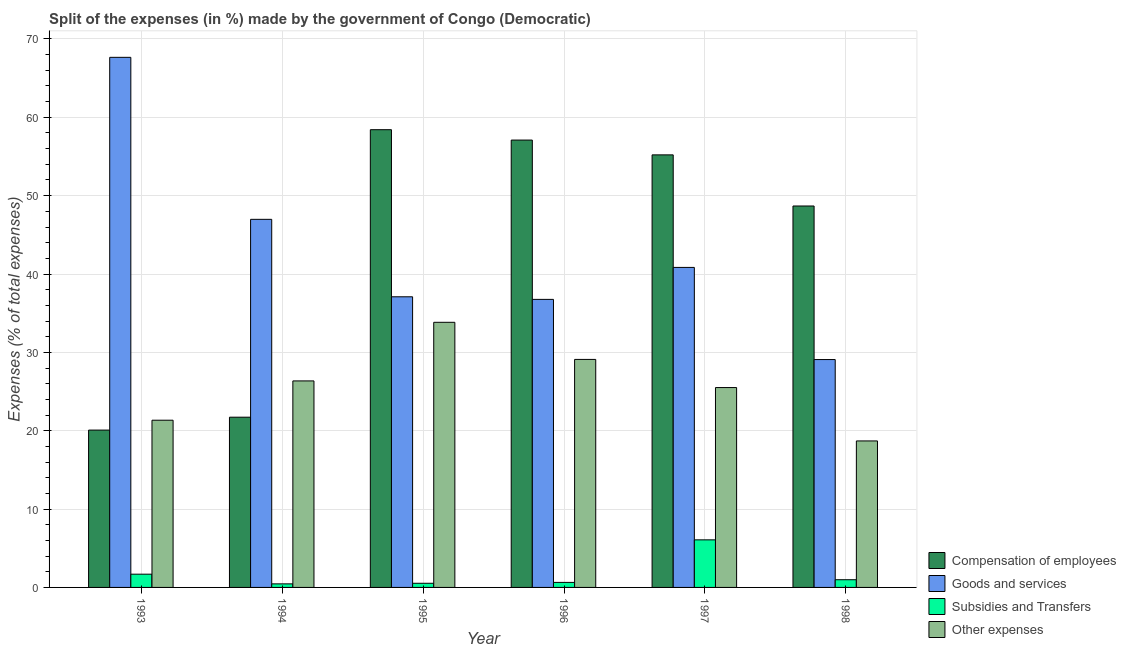How many groups of bars are there?
Provide a succinct answer. 6. What is the percentage of amount spent on other expenses in 1996?
Provide a short and direct response. 29.1. Across all years, what is the maximum percentage of amount spent on compensation of employees?
Give a very brief answer. 58.42. Across all years, what is the minimum percentage of amount spent on subsidies?
Keep it short and to the point. 0.45. In which year was the percentage of amount spent on goods and services minimum?
Ensure brevity in your answer.  1998. What is the total percentage of amount spent on compensation of employees in the graph?
Your answer should be very brief. 261.21. What is the difference between the percentage of amount spent on compensation of employees in 1994 and that in 1996?
Offer a very short reply. -35.37. What is the difference between the percentage of amount spent on other expenses in 1997 and the percentage of amount spent on compensation of employees in 1994?
Keep it short and to the point. -0.85. What is the average percentage of amount spent on goods and services per year?
Give a very brief answer. 43.07. In how many years, is the percentage of amount spent on subsidies greater than 4 %?
Provide a succinct answer. 1. What is the ratio of the percentage of amount spent on goods and services in 1994 to that in 1995?
Your answer should be very brief. 1.27. What is the difference between the highest and the second highest percentage of amount spent on compensation of employees?
Offer a terse response. 1.32. What is the difference between the highest and the lowest percentage of amount spent on other expenses?
Your answer should be very brief. 15.14. In how many years, is the percentage of amount spent on subsidies greater than the average percentage of amount spent on subsidies taken over all years?
Give a very brief answer. 1. Is it the case that in every year, the sum of the percentage of amount spent on goods and services and percentage of amount spent on compensation of employees is greater than the sum of percentage of amount spent on other expenses and percentage of amount spent on subsidies?
Provide a short and direct response. Yes. What does the 1st bar from the left in 1994 represents?
Give a very brief answer. Compensation of employees. What does the 3rd bar from the right in 1995 represents?
Give a very brief answer. Goods and services. Is it the case that in every year, the sum of the percentage of amount spent on compensation of employees and percentage of amount spent on goods and services is greater than the percentage of amount spent on subsidies?
Give a very brief answer. Yes. How many bars are there?
Keep it short and to the point. 24. What is the difference between two consecutive major ticks on the Y-axis?
Ensure brevity in your answer.  10. Does the graph contain grids?
Provide a succinct answer. Yes. Where does the legend appear in the graph?
Ensure brevity in your answer.  Bottom right. What is the title of the graph?
Your answer should be very brief. Split of the expenses (in %) made by the government of Congo (Democratic). Does "Norway" appear as one of the legend labels in the graph?
Your answer should be compact. No. What is the label or title of the X-axis?
Your answer should be compact. Year. What is the label or title of the Y-axis?
Your response must be concise. Expenses (% of total expenses). What is the Expenses (% of total expenses) of Compensation of employees in 1993?
Keep it short and to the point. 20.08. What is the Expenses (% of total expenses) of Goods and services in 1993?
Your answer should be compact. 67.66. What is the Expenses (% of total expenses) of Subsidies and Transfers in 1993?
Your answer should be very brief. 1.69. What is the Expenses (% of total expenses) of Other expenses in 1993?
Provide a short and direct response. 21.34. What is the Expenses (% of total expenses) in Compensation of employees in 1994?
Make the answer very short. 21.73. What is the Expenses (% of total expenses) of Goods and services in 1994?
Make the answer very short. 46.98. What is the Expenses (% of total expenses) in Subsidies and Transfers in 1994?
Provide a succinct answer. 0.45. What is the Expenses (% of total expenses) in Other expenses in 1994?
Your response must be concise. 26.36. What is the Expenses (% of total expenses) of Compensation of employees in 1995?
Give a very brief answer. 58.42. What is the Expenses (% of total expenses) of Goods and services in 1995?
Offer a terse response. 37.09. What is the Expenses (% of total expenses) of Subsidies and Transfers in 1995?
Your response must be concise. 0.53. What is the Expenses (% of total expenses) of Other expenses in 1995?
Provide a succinct answer. 33.84. What is the Expenses (% of total expenses) in Compensation of employees in 1996?
Your response must be concise. 57.1. What is the Expenses (% of total expenses) of Goods and services in 1996?
Your response must be concise. 36.76. What is the Expenses (% of total expenses) in Subsidies and Transfers in 1996?
Provide a succinct answer. 0.64. What is the Expenses (% of total expenses) in Other expenses in 1996?
Offer a very short reply. 29.1. What is the Expenses (% of total expenses) of Compensation of employees in 1997?
Make the answer very short. 55.21. What is the Expenses (% of total expenses) of Goods and services in 1997?
Your answer should be compact. 40.84. What is the Expenses (% of total expenses) of Subsidies and Transfers in 1997?
Your answer should be compact. 6.07. What is the Expenses (% of total expenses) in Other expenses in 1997?
Offer a very short reply. 25.51. What is the Expenses (% of total expenses) in Compensation of employees in 1998?
Your answer should be compact. 48.68. What is the Expenses (% of total expenses) in Goods and services in 1998?
Your response must be concise. 29.08. What is the Expenses (% of total expenses) of Subsidies and Transfers in 1998?
Offer a very short reply. 0.98. What is the Expenses (% of total expenses) in Other expenses in 1998?
Offer a very short reply. 18.7. Across all years, what is the maximum Expenses (% of total expenses) of Compensation of employees?
Give a very brief answer. 58.42. Across all years, what is the maximum Expenses (% of total expenses) in Goods and services?
Give a very brief answer. 67.66. Across all years, what is the maximum Expenses (% of total expenses) in Subsidies and Transfers?
Your answer should be compact. 6.07. Across all years, what is the maximum Expenses (% of total expenses) of Other expenses?
Your response must be concise. 33.84. Across all years, what is the minimum Expenses (% of total expenses) of Compensation of employees?
Give a very brief answer. 20.08. Across all years, what is the minimum Expenses (% of total expenses) in Goods and services?
Your response must be concise. 29.08. Across all years, what is the minimum Expenses (% of total expenses) of Subsidies and Transfers?
Ensure brevity in your answer.  0.45. Across all years, what is the minimum Expenses (% of total expenses) of Other expenses?
Provide a short and direct response. 18.7. What is the total Expenses (% of total expenses) in Compensation of employees in the graph?
Offer a very short reply. 261.21. What is the total Expenses (% of total expenses) of Goods and services in the graph?
Your answer should be very brief. 258.42. What is the total Expenses (% of total expenses) of Subsidies and Transfers in the graph?
Provide a succinct answer. 10.37. What is the total Expenses (% of total expenses) of Other expenses in the graph?
Give a very brief answer. 154.84. What is the difference between the Expenses (% of total expenses) in Compensation of employees in 1993 and that in 1994?
Offer a very short reply. -1.65. What is the difference between the Expenses (% of total expenses) of Goods and services in 1993 and that in 1994?
Your response must be concise. 20.68. What is the difference between the Expenses (% of total expenses) in Subsidies and Transfers in 1993 and that in 1994?
Provide a succinct answer. 1.24. What is the difference between the Expenses (% of total expenses) of Other expenses in 1993 and that in 1994?
Ensure brevity in your answer.  -5.01. What is the difference between the Expenses (% of total expenses) in Compensation of employees in 1993 and that in 1995?
Give a very brief answer. -38.34. What is the difference between the Expenses (% of total expenses) in Goods and services in 1993 and that in 1995?
Your response must be concise. 30.56. What is the difference between the Expenses (% of total expenses) in Subsidies and Transfers in 1993 and that in 1995?
Your answer should be compact. 1.16. What is the difference between the Expenses (% of total expenses) of Other expenses in 1993 and that in 1995?
Give a very brief answer. -12.5. What is the difference between the Expenses (% of total expenses) of Compensation of employees in 1993 and that in 1996?
Give a very brief answer. -37.02. What is the difference between the Expenses (% of total expenses) of Goods and services in 1993 and that in 1996?
Provide a short and direct response. 30.89. What is the difference between the Expenses (% of total expenses) of Subsidies and Transfers in 1993 and that in 1996?
Your answer should be compact. 1.05. What is the difference between the Expenses (% of total expenses) of Other expenses in 1993 and that in 1996?
Provide a short and direct response. -7.76. What is the difference between the Expenses (% of total expenses) of Compensation of employees in 1993 and that in 1997?
Offer a terse response. -35.13. What is the difference between the Expenses (% of total expenses) in Goods and services in 1993 and that in 1997?
Your answer should be very brief. 26.81. What is the difference between the Expenses (% of total expenses) in Subsidies and Transfers in 1993 and that in 1997?
Provide a short and direct response. -4.38. What is the difference between the Expenses (% of total expenses) in Other expenses in 1993 and that in 1997?
Offer a very short reply. -4.17. What is the difference between the Expenses (% of total expenses) in Compensation of employees in 1993 and that in 1998?
Your answer should be very brief. -28.6. What is the difference between the Expenses (% of total expenses) in Goods and services in 1993 and that in 1998?
Provide a succinct answer. 38.57. What is the difference between the Expenses (% of total expenses) in Subsidies and Transfers in 1993 and that in 1998?
Your answer should be compact. 0.71. What is the difference between the Expenses (% of total expenses) in Other expenses in 1993 and that in 1998?
Provide a short and direct response. 2.65. What is the difference between the Expenses (% of total expenses) of Compensation of employees in 1994 and that in 1995?
Give a very brief answer. -36.69. What is the difference between the Expenses (% of total expenses) in Goods and services in 1994 and that in 1995?
Your response must be concise. 9.89. What is the difference between the Expenses (% of total expenses) in Subsidies and Transfers in 1994 and that in 1995?
Provide a short and direct response. -0.08. What is the difference between the Expenses (% of total expenses) of Other expenses in 1994 and that in 1995?
Keep it short and to the point. -7.48. What is the difference between the Expenses (% of total expenses) in Compensation of employees in 1994 and that in 1996?
Provide a succinct answer. -35.37. What is the difference between the Expenses (% of total expenses) in Goods and services in 1994 and that in 1996?
Make the answer very short. 10.22. What is the difference between the Expenses (% of total expenses) in Subsidies and Transfers in 1994 and that in 1996?
Your answer should be compact. -0.19. What is the difference between the Expenses (% of total expenses) in Other expenses in 1994 and that in 1996?
Your answer should be very brief. -2.74. What is the difference between the Expenses (% of total expenses) in Compensation of employees in 1994 and that in 1997?
Make the answer very short. -33.48. What is the difference between the Expenses (% of total expenses) of Goods and services in 1994 and that in 1997?
Provide a short and direct response. 6.14. What is the difference between the Expenses (% of total expenses) of Subsidies and Transfers in 1994 and that in 1997?
Your answer should be compact. -5.62. What is the difference between the Expenses (% of total expenses) in Other expenses in 1994 and that in 1997?
Keep it short and to the point. 0.85. What is the difference between the Expenses (% of total expenses) in Compensation of employees in 1994 and that in 1998?
Give a very brief answer. -26.95. What is the difference between the Expenses (% of total expenses) in Goods and services in 1994 and that in 1998?
Your answer should be compact. 17.9. What is the difference between the Expenses (% of total expenses) in Subsidies and Transfers in 1994 and that in 1998?
Offer a terse response. -0.53. What is the difference between the Expenses (% of total expenses) in Other expenses in 1994 and that in 1998?
Provide a succinct answer. 7.66. What is the difference between the Expenses (% of total expenses) of Compensation of employees in 1995 and that in 1996?
Keep it short and to the point. 1.32. What is the difference between the Expenses (% of total expenses) of Goods and services in 1995 and that in 1996?
Keep it short and to the point. 0.33. What is the difference between the Expenses (% of total expenses) of Subsidies and Transfers in 1995 and that in 1996?
Provide a succinct answer. -0.11. What is the difference between the Expenses (% of total expenses) of Other expenses in 1995 and that in 1996?
Your answer should be very brief. 4.74. What is the difference between the Expenses (% of total expenses) in Compensation of employees in 1995 and that in 1997?
Offer a terse response. 3.21. What is the difference between the Expenses (% of total expenses) in Goods and services in 1995 and that in 1997?
Provide a short and direct response. -3.75. What is the difference between the Expenses (% of total expenses) in Subsidies and Transfers in 1995 and that in 1997?
Make the answer very short. -5.54. What is the difference between the Expenses (% of total expenses) of Other expenses in 1995 and that in 1997?
Keep it short and to the point. 8.33. What is the difference between the Expenses (% of total expenses) in Compensation of employees in 1995 and that in 1998?
Offer a terse response. 9.74. What is the difference between the Expenses (% of total expenses) of Goods and services in 1995 and that in 1998?
Give a very brief answer. 8.01. What is the difference between the Expenses (% of total expenses) of Subsidies and Transfers in 1995 and that in 1998?
Make the answer very short. -0.45. What is the difference between the Expenses (% of total expenses) of Other expenses in 1995 and that in 1998?
Give a very brief answer. 15.14. What is the difference between the Expenses (% of total expenses) in Compensation of employees in 1996 and that in 1997?
Provide a succinct answer. 1.89. What is the difference between the Expenses (% of total expenses) of Goods and services in 1996 and that in 1997?
Your answer should be very brief. -4.08. What is the difference between the Expenses (% of total expenses) of Subsidies and Transfers in 1996 and that in 1997?
Provide a succinct answer. -5.43. What is the difference between the Expenses (% of total expenses) in Other expenses in 1996 and that in 1997?
Ensure brevity in your answer.  3.59. What is the difference between the Expenses (% of total expenses) of Compensation of employees in 1996 and that in 1998?
Your response must be concise. 8.41. What is the difference between the Expenses (% of total expenses) of Goods and services in 1996 and that in 1998?
Make the answer very short. 7.68. What is the difference between the Expenses (% of total expenses) in Subsidies and Transfers in 1996 and that in 1998?
Keep it short and to the point. -0.34. What is the difference between the Expenses (% of total expenses) of Other expenses in 1996 and that in 1998?
Ensure brevity in your answer.  10.4. What is the difference between the Expenses (% of total expenses) in Compensation of employees in 1997 and that in 1998?
Provide a short and direct response. 6.52. What is the difference between the Expenses (% of total expenses) in Goods and services in 1997 and that in 1998?
Offer a terse response. 11.76. What is the difference between the Expenses (% of total expenses) of Subsidies and Transfers in 1997 and that in 1998?
Provide a short and direct response. 5.09. What is the difference between the Expenses (% of total expenses) in Other expenses in 1997 and that in 1998?
Offer a very short reply. 6.81. What is the difference between the Expenses (% of total expenses) in Compensation of employees in 1993 and the Expenses (% of total expenses) in Goods and services in 1994?
Offer a terse response. -26.9. What is the difference between the Expenses (% of total expenses) in Compensation of employees in 1993 and the Expenses (% of total expenses) in Subsidies and Transfers in 1994?
Give a very brief answer. 19.63. What is the difference between the Expenses (% of total expenses) in Compensation of employees in 1993 and the Expenses (% of total expenses) in Other expenses in 1994?
Offer a terse response. -6.28. What is the difference between the Expenses (% of total expenses) in Goods and services in 1993 and the Expenses (% of total expenses) in Subsidies and Transfers in 1994?
Your response must be concise. 67.2. What is the difference between the Expenses (% of total expenses) in Goods and services in 1993 and the Expenses (% of total expenses) in Other expenses in 1994?
Your answer should be compact. 41.3. What is the difference between the Expenses (% of total expenses) of Subsidies and Transfers in 1993 and the Expenses (% of total expenses) of Other expenses in 1994?
Keep it short and to the point. -24.67. What is the difference between the Expenses (% of total expenses) of Compensation of employees in 1993 and the Expenses (% of total expenses) of Goods and services in 1995?
Your response must be concise. -17.01. What is the difference between the Expenses (% of total expenses) of Compensation of employees in 1993 and the Expenses (% of total expenses) of Subsidies and Transfers in 1995?
Give a very brief answer. 19.55. What is the difference between the Expenses (% of total expenses) in Compensation of employees in 1993 and the Expenses (% of total expenses) in Other expenses in 1995?
Provide a short and direct response. -13.76. What is the difference between the Expenses (% of total expenses) in Goods and services in 1993 and the Expenses (% of total expenses) in Subsidies and Transfers in 1995?
Ensure brevity in your answer.  67.13. What is the difference between the Expenses (% of total expenses) in Goods and services in 1993 and the Expenses (% of total expenses) in Other expenses in 1995?
Make the answer very short. 33.82. What is the difference between the Expenses (% of total expenses) of Subsidies and Transfers in 1993 and the Expenses (% of total expenses) of Other expenses in 1995?
Provide a short and direct response. -32.15. What is the difference between the Expenses (% of total expenses) in Compensation of employees in 1993 and the Expenses (% of total expenses) in Goods and services in 1996?
Offer a very short reply. -16.68. What is the difference between the Expenses (% of total expenses) of Compensation of employees in 1993 and the Expenses (% of total expenses) of Subsidies and Transfers in 1996?
Ensure brevity in your answer.  19.44. What is the difference between the Expenses (% of total expenses) of Compensation of employees in 1993 and the Expenses (% of total expenses) of Other expenses in 1996?
Offer a very short reply. -9.02. What is the difference between the Expenses (% of total expenses) in Goods and services in 1993 and the Expenses (% of total expenses) in Subsidies and Transfers in 1996?
Provide a succinct answer. 67.01. What is the difference between the Expenses (% of total expenses) of Goods and services in 1993 and the Expenses (% of total expenses) of Other expenses in 1996?
Provide a succinct answer. 38.56. What is the difference between the Expenses (% of total expenses) in Subsidies and Transfers in 1993 and the Expenses (% of total expenses) in Other expenses in 1996?
Your answer should be compact. -27.41. What is the difference between the Expenses (% of total expenses) in Compensation of employees in 1993 and the Expenses (% of total expenses) in Goods and services in 1997?
Give a very brief answer. -20.76. What is the difference between the Expenses (% of total expenses) of Compensation of employees in 1993 and the Expenses (% of total expenses) of Subsidies and Transfers in 1997?
Give a very brief answer. 14.01. What is the difference between the Expenses (% of total expenses) of Compensation of employees in 1993 and the Expenses (% of total expenses) of Other expenses in 1997?
Keep it short and to the point. -5.43. What is the difference between the Expenses (% of total expenses) of Goods and services in 1993 and the Expenses (% of total expenses) of Subsidies and Transfers in 1997?
Keep it short and to the point. 61.58. What is the difference between the Expenses (% of total expenses) in Goods and services in 1993 and the Expenses (% of total expenses) in Other expenses in 1997?
Offer a very short reply. 42.15. What is the difference between the Expenses (% of total expenses) of Subsidies and Transfers in 1993 and the Expenses (% of total expenses) of Other expenses in 1997?
Make the answer very short. -23.82. What is the difference between the Expenses (% of total expenses) in Compensation of employees in 1993 and the Expenses (% of total expenses) in Goods and services in 1998?
Provide a succinct answer. -9. What is the difference between the Expenses (% of total expenses) of Compensation of employees in 1993 and the Expenses (% of total expenses) of Subsidies and Transfers in 1998?
Give a very brief answer. 19.1. What is the difference between the Expenses (% of total expenses) in Compensation of employees in 1993 and the Expenses (% of total expenses) in Other expenses in 1998?
Offer a terse response. 1.38. What is the difference between the Expenses (% of total expenses) in Goods and services in 1993 and the Expenses (% of total expenses) in Subsidies and Transfers in 1998?
Provide a succinct answer. 66.67. What is the difference between the Expenses (% of total expenses) in Goods and services in 1993 and the Expenses (% of total expenses) in Other expenses in 1998?
Ensure brevity in your answer.  48.96. What is the difference between the Expenses (% of total expenses) in Subsidies and Transfers in 1993 and the Expenses (% of total expenses) in Other expenses in 1998?
Provide a succinct answer. -17.01. What is the difference between the Expenses (% of total expenses) of Compensation of employees in 1994 and the Expenses (% of total expenses) of Goods and services in 1995?
Offer a very short reply. -15.37. What is the difference between the Expenses (% of total expenses) in Compensation of employees in 1994 and the Expenses (% of total expenses) in Subsidies and Transfers in 1995?
Make the answer very short. 21.2. What is the difference between the Expenses (% of total expenses) of Compensation of employees in 1994 and the Expenses (% of total expenses) of Other expenses in 1995?
Ensure brevity in your answer.  -12.11. What is the difference between the Expenses (% of total expenses) of Goods and services in 1994 and the Expenses (% of total expenses) of Subsidies and Transfers in 1995?
Provide a short and direct response. 46.45. What is the difference between the Expenses (% of total expenses) of Goods and services in 1994 and the Expenses (% of total expenses) of Other expenses in 1995?
Your response must be concise. 13.14. What is the difference between the Expenses (% of total expenses) of Subsidies and Transfers in 1994 and the Expenses (% of total expenses) of Other expenses in 1995?
Make the answer very short. -33.38. What is the difference between the Expenses (% of total expenses) of Compensation of employees in 1994 and the Expenses (% of total expenses) of Goods and services in 1996?
Your response must be concise. -15.04. What is the difference between the Expenses (% of total expenses) in Compensation of employees in 1994 and the Expenses (% of total expenses) in Subsidies and Transfers in 1996?
Keep it short and to the point. 21.09. What is the difference between the Expenses (% of total expenses) of Compensation of employees in 1994 and the Expenses (% of total expenses) of Other expenses in 1996?
Give a very brief answer. -7.37. What is the difference between the Expenses (% of total expenses) in Goods and services in 1994 and the Expenses (% of total expenses) in Subsidies and Transfers in 1996?
Ensure brevity in your answer.  46.34. What is the difference between the Expenses (% of total expenses) in Goods and services in 1994 and the Expenses (% of total expenses) in Other expenses in 1996?
Your answer should be compact. 17.88. What is the difference between the Expenses (% of total expenses) of Subsidies and Transfers in 1994 and the Expenses (% of total expenses) of Other expenses in 1996?
Your response must be concise. -28.65. What is the difference between the Expenses (% of total expenses) in Compensation of employees in 1994 and the Expenses (% of total expenses) in Goods and services in 1997?
Your answer should be very brief. -19.11. What is the difference between the Expenses (% of total expenses) of Compensation of employees in 1994 and the Expenses (% of total expenses) of Subsidies and Transfers in 1997?
Offer a terse response. 15.65. What is the difference between the Expenses (% of total expenses) in Compensation of employees in 1994 and the Expenses (% of total expenses) in Other expenses in 1997?
Your answer should be very brief. -3.78. What is the difference between the Expenses (% of total expenses) of Goods and services in 1994 and the Expenses (% of total expenses) of Subsidies and Transfers in 1997?
Provide a short and direct response. 40.91. What is the difference between the Expenses (% of total expenses) of Goods and services in 1994 and the Expenses (% of total expenses) of Other expenses in 1997?
Your response must be concise. 21.47. What is the difference between the Expenses (% of total expenses) of Subsidies and Transfers in 1994 and the Expenses (% of total expenses) of Other expenses in 1997?
Offer a terse response. -25.05. What is the difference between the Expenses (% of total expenses) of Compensation of employees in 1994 and the Expenses (% of total expenses) of Goods and services in 1998?
Ensure brevity in your answer.  -7.36. What is the difference between the Expenses (% of total expenses) of Compensation of employees in 1994 and the Expenses (% of total expenses) of Subsidies and Transfers in 1998?
Offer a very short reply. 20.75. What is the difference between the Expenses (% of total expenses) in Compensation of employees in 1994 and the Expenses (% of total expenses) in Other expenses in 1998?
Make the answer very short. 3.03. What is the difference between the Expenses (% of total expenses) in Goods and services in 1994 and the Expenses (% of total expenses) in Subsidies and Transfers in 1998?
Offer a terse response. 46. What is the difference between the Expenses (% of total expenses) in Goods and services in 1994 and the Expenses (% of total expenses) in Other expenses in 1998?
Make the answer very short. 28.28. What is the difference between the Expenses (% of total expenses) in Subsidies and Transfers in 1994 and the Expenses (% of total expenses) in Other expenses in 1998?
Offer a terse response. -18.24. What is the difference between the Expenses (% of total expenses) in Compensation of employees in 1995 and the Expenses (% of total expenses) in Goods and services in 1996?
Keep it short and to the point. 21.66. What is the difference between the Expenses (% of total expenses) of Compensation of employees in 1995 and the Expenses (% of total expenses) of Subsidies and Transfers in 1996?
Your response must be concise. 57.78. What is the difference between the Expenses (% of total expenses) of Compensation of employees in 1995 and the Expenses (% of total expenses) of Other expenses in 1996?
Ensure brevity in your answer.  29.32. What is the difference between the Expenses (% of total expenses) of Goods and services in 1995 and the Expenses (% of total expenses) of Subsidies and Transfers in 1996?
Give a very brief answer. 36.45. What is the difference between the Expenses (% of total expenses) in Goods and services in 1995 and the Expenses (% of total expenses) in Other expenses in 1996?
Give a very brief answer. 7.99. What is the difference between the Expenses (% of total expenses) in Subsidies and Transfers in 1995 and the Expenses (% of total expenses) in Other expenses in 1996?
Offer a terse response. -28.57. What is the difference between the Expenses (% of total expenses) in Compensation of employees in 1995 and the Expenses (% of total expenses) in Goods and services in 1997?
Offer a terse response. 17.58. What is the difference between the Expenses (% of total expenses) in Compensation of employees in 1995 and the Expenses (% of total expenses) in Subsidies and Transfers in 1997?
Provide a short and direct response. 52.35. What is the difference between the Expenses (% of total expenses) in Compensation of employees in 1995 and the Expenses (% of total expenses) in Other expenses in 1997?
Your answer should be compact. 32.91. What is the difference between the Expenses (% of total expenses) of Goods and services in 1995 and the Expenses (% of total expenses) of Subsidies and Transfers in 1997?
Keep it short and to the point. 31.02. What is the difference between the Expenses (% of total expenses) of Goods and services in 1995 and the Expenses (% of total expenses) of Other expenses in 1997?
Provide a succinct answer. 11.58. What is the difference between the Expenses (% of total expenses) in Subsidies and Transfers in 1995 and the Expenses (% of total expenses) in Other expenses in 1997?
Offer a very short reply. -24.98. What is the difference between the Expenses (% of total expenses) of Compensation of employees in 1995 and the Expenses (% of total expenses) of Goods and services in 1998?
Give a very brief answer. 29.34. What is the difference between the Expenses (% of total expenses) of Compensation of employees in 1995 and the Expenses (% of total expenses) of Subsidies and Transfers in 1998?
Your answer should be very brief. 57.44. What is the difference between the Expenses (% of total expenses) of Compensation of employees in 1995 and the Expenses (% of total expenses) of Other expenses in 1998?
Ensure brevity in your answer.  39.72. What is the difference between the Expenses (% of total expenses) in Goods and services in 1995 and the Expenses (% of total expenses) in Subsidies and Transfers in 1998?
Provide a succinct answer. 36.11. What is the difference between the Expenses (% of total expenses) of Goods and services in 1995 and the Expenses (% of total expenses) of Other expenses in 1998?
Offer a terse response. 18.4. What is the difference between the Expenses (% of total expenses) in Subsidies and Transfers in 1995 and the Expenses (% of total expenses) in Other expenses in 1998?
Provide a succinct answer. -18.17. What is the difference between the Expenses (% of total expenses) in Compensation of employees in 1996 and the Expenses (% of total expenses) in Goods and services in 1997?
Offer a terse response. 16.25. What is the difference between the Expenses (% of total expenses) in Compensation of employees in 1996 and the Expenses (% of total expenses) in Subsidies and Transfers in 1997?
Make the answer very short. 51.02. What is the difference between the Expenses (% of total expenses) in Compensation of employees in 1996 and the Expenses (% of total expenses) in Other expenses in 1997?
Provide a short and direct response. 31.59. What is the difference between the Expenses (% of total expenses) of Goods and services in 1996 and the Expenses (% of total expenses) of Subsidies and Transfers in 1997?
Make the answer very short. 30.69. What is the difference between the Expenses (% of total expenses) of Goods and services in 1996 and the Expenses (% of total expenses) of Other expenses in 1997?
Give a very brief answer. 11.25. What is the difference between the Expenses (% of total expenses) of Subsidies and Transfers in 1996 and the Expenses (% of total expenses) of Other expenses in 1997?
Offer a very short reply. -24.87. What is the difference between the Expenses (% of total expenses) in Compensation of employees in 1996 and the Expenses (% of total expenses) in Goods and services in 1998?
Keep it short and to the point. 28.01. What is the difference between the Expenses (% of total expenses) in Compensation of employees in 1996 and the Expenses (% of total expenses) in Subsidies and Transfers in 1998?
Offer a very short reply. 56.11. What is the difference between the Expenses (% of total expenses) in Compensation of employees in 1996 and the Expenses (% of total expenses) in Other expenses in 1998?
Provide a short and direct response. 38.4. What is the difference between the Expenses (% of total expenses) in Goods and services in 1996 and the Expenses (% of total expenses) in Subsidies and Transfers in 1998?
Give a very brief answer. 35.78. What is the difference between the Expenses (% of total expenses) in Goods and services in 1996 and the Expenses (% of total expenses) in Other expenses in 1998?
Give a very brief answer. 18.07. What is the difference between the Expenses (% of total expenses) in Subsidies and Transfers in 1996 and the Expenses (% of total expenses) in Other expenses in 1998?
Your answer should be very brief. -18.05. What is the difference between the Expenses (% of total expenses) in Compensation of employees in 1997 and the Expenses (% of total expenses) in Goods and services in 1998?
Offer a very short reply. 26.12. What is the difference between the Expenses (% of total expenses) of Compensation of employees in 1997 and the Expenses (% of total expenses) of Subsidies and Transfers in 1998?
Your answer should be compact. 54.22. What is the difference between the Expenses (% of total expenses) in Compensation of employees in 1997 and the Expenses (% of total expenses) in Other expenses in 1998?
Offer a very short reply. 36.51. What is the difference between the Expenses (% of total expenses) in Goods and services in 1997 and the Expenses (% of total expenses) in Subsidies and Transfers in 1998?
Your answer should be very brief. 39.86. What is the difference between the Expenses (% of total expenses) of Goods and services in 1997 and the Expenses (% of total expenses) of Other expenses in 1998?
Keep it short and to the point. 22.15. What is the difference between the Expenses (% of total expenses) of Subsidies and Transfers in 1997 and the Expenses (% of total expenses) of Other expenses in 1998?
Give a very brief answer. -12.62. What is the average Expenses (% of total expenses) in Compensation of employees per year?
Your answer should be compact. 43.54. What is the average Expenses (% of total expenses) of Goods and services per year?
Give a very brief answer. 43.07. What is the average Expenses (% of total expenses) of Subsidies and Transfers per year?
Offer a very short reply. 1.73. What is the average Expenses (% of total expenses) in Other expenses per year?
Your answer should be compact. 25.81. In the year 1993, what is the difference between the Expenses (% of total expenses) in Compensation of employees and Expenses (% of total expenses) in Goods and services?
Provide a succinct answer. -47.58. In the year 1993, what is the difference between the Expenses (% of total expenses) in Compensation of employees and Expenses (% of total expenses) in Subsidies and Transfers?
Make the answer very short. 18.39. In the year 1993, what is the difference between the Expenses (% of total expenses) of Compensation of employees and Expenses (% of total expenses) of Other expenses?
Keep it short and to the point. -1.26. In the year 1993, what is the difference between the Expenses (% of total expenses) in Goods and services and Expenses (% of total expenses) in Subsidies and Transfers?
Make the answer very short. 65.97. In the year 1993, what is the difference between the Expenses (% of total expenses) of Goods and services and Expenses (% of total expenses) of Other expenses?
Your answer should be very brief. 46.31. In the year 1993, what is the difference between the Expenses (% of total expenses) in Subsidies and Transfers and Expenses (% of total expenses) in Other expenses?
Provide a short and direct response. -19.65. In the year 1994, what is the difference between the Expenses (% of total expenses) of Compensation of employees and Expenses (% of total expenses) of Goods and services?
Ensure brevity in your answer.  -25.25. In the year 1994, what is the difference between the Expenses (% of total expenses) of Compensation of employees and Expenses (% of total expenses) of Subsidies and Transfers?
Your response must be concise. 21.27. In the year 1994, what is the difference between the Expenses (% of total expenses) in Compensation of employees and Expenses (% of total expenses) in Other expenses?
Your answer should be compact. -4.63. In the year 1994, what is the difference between the Expenses (% of total expenses) of Goods and services and Expenses (% of total expenses) of Subsidies and Transfers?
Offer a terse response. 46.53. In the year 1994, what is the difference between the Expenses (% of total expenses) of Goods and services and Expenses (% of total expenses) of Other expenses?
Provide a short and direct response. 20.62. In the year 1994, what is the difference between the Expenses (% of total expenses) of Subsidies and Transfers and Expenses (% of total expenses) of Other expenses?
Give a very brief answer. -25.9. In the year 1995, what is the difference between the Expenses (% of total expenses) in Compensation of employees and Expenses (% of total expenses) in Goods and services?
Give a very brief answer. 21.33. In the year 1995, what is the difference between the Expenses (% of total expenses) in Compensation of employees and Expenses (% of total expenses) in Subsidies and Transfers?
Your answer should be compact. 57.89. In the year 1995, what is the difference between the Expenses (% of total expenses) of Compensation of employees and Expenses (% of total expenses) of Other expenses?
Your response must be concise. 24.58. In the year 1995, what is the difference between the Expenses (% of total expenses) of Goods and services and Expenses (% of total expenses) of Subsidies and Transfers?
Your response must be concise. 36.56. In the year 1995, what is the difference between the Expenses (% of total expenses) of Goods and services and Expenses (% of total expenses) of Other expenses?
Offer a very short reply. 3.25. In the year 1995, what is the difference between the Expenses (% of total expenses) in Subsidies and Transfers and Expenses (% of total expenses) in Other expenses?
Offer a terse response. -33.31. In the year 1996, what is the difference between the Expenses (% of total expenses) in Compensation of employees and Expenses (% of total expenses) in Goods and services?
Ensure brevity in your answer.  20.33. In the year 1996, what is the difference between the Expenses (% of total expenses) of Compensation of employees and Expenses (% of total expenses) of Subsidies and Transfers?
Your answer should be compact. 56.45. In the year 1996, what is the difference between the Expenses (% of total expenses) in Compensation of employees and Expenses (% of total expenses) in Other expenses?
Offer a very short reply. 28. In the year 1996, what is the difference between the Expenses (% of total expenses) of Goods and services and Expenses (% of total expenses) of Subsidies and Transfers?
Offer a very short reply. 36.12. In the year 1996, what is the difference between the Expenses (% of total expenses) of Goods and services and Expenses (% of total expenses) of Other expenses?
Provide a succinct answer. 7.66. In the year 1996, what is the difference between the Expenses (% of total expenses) in Subsidies and Transfers and Expenses (% of total expenses) in Other expenses?
Your answer should be compact. -28.46. In the year 1997, what is the difference between the Expenses (% of total expenses) in Compensation of employees and Expenses (% of total expenses) in Goods and services?
Your answer should be very brief. 14.36. In the year 1997, what is the difference between the Expenses (% of total expenses) in Compensation of employees and Expenses (% of total expenses) in Subsidies and Transfers?
Provide a succinct answer. 49.13. In the year 1997, what is the difference between the Expenses (% of total expenses) in Compensation of employees and Expenses (% of total expenses) in Other expenses?
Provide a succinct answer. 29.7. In the year 1997, what is the difference between the Expenses (% of total expenses) in Goods and services and Expenses (% of total expenses) in Subsidies and Transfers?
Make the answer very short. 34.77. In the year 1997, what is the difference between the Expenses (% of total expenses) in Goods and services and Expenses (% of total expenses) in Other expenses?
Your answer should be compact. 15.33. In the year 1997, what is the difference between the Expenses (% of total expenses) in Subsidies and Transfers and Expenses (% of total expenses) in Other expenses?
Provide a succinct answer. -19.44. In the year 1998, what is the difference between the Expenses (% of total expenses) of Compensation of employees and Expenses (% of total expenses) of Goods and services?
Provide a short and direct response. 19.6. In the year 1998, what is the difference between the Expenses (% of total expenses) of Compensation of employees and Expenses (% of total expenses) of Subsidies and Transfers?
Your answer should be compact. 47.7. In the year 1998, what is the difference between the Expenses (% of total expenses) in Compensation of employees and Expenses (% of total expenses) in Other expenses?
Offer a terse response. 29.99. In the year 1998, what is the difference between the Expenses (% of total expenses) of Goods and services and Expenses (% of total expenses) of Subsidies and Transfers?
Keep it short and to the point. 28.1. In the year 1998, what is the difference between the Expenses (% of total expenses) in Goods and services and Expenses (% of total expenses) in Other expenses?
Provide a short and direct response. 10.39. In the year 1998, what is the difference between the Expenses (% of total expenses) of Subsidies and Transfers and Expenses (% of total expenses) of Other expenses?
Provide a short and direct response. -17.71. What is the ratio of the Expenses (% of total expenses) in Compensation of employees in 1993 to that in 1994?
Keep it short and to the point. 0.92. What is the ratio of the Expenses (% of total expenses) in Goods and services in 1993 to that in 1994?
Provide a succinct answer. 1.44. What is the ratio of the Expenses (% of total expenses) of Subsidies and Transfers in 1993 to that in 1994?
Ensure brevity in your answer.  3.72. What is the ratio of the Expenses (% of total expenses) in Other expenses in 1993 to that in 1994?
Provide a short and direct response. 0.81. What is the ratio of the Expenses (% of total expenses) in Compensation of employees in 1993 to that in 1995?
Your answer should be compact. 0.34. What is the ratio of the Expenses (% of total expenses) of Goods and services in 1993 to that in 1995?
Your answer should be compact. 1.82. What is the ratio of the Expenses (% of total expenses) of Subsidies and Transfers in 1993 to that in 1995?
Ensure brevity in your answer.  3.19. What is the ratio of the Expenses (% of total expenses) of Other expenses in 1993 to that in 1995?
Offer a very short reply. 0.63. What is the ratio of the Expenses (% of total expenses) of Compensation of employees in 1993 to that in 1996?
Offer a terse response. 0.35. What is the ratio of the Expenses (% of total expenses) in Goods and services in 1993 to that in 1996?
Provide a short and direct response. 1.84. What is the ratio of the Expenses (% of total expenses) in Subsidies and Transfers in 1993 to that in 1996?
Keep it short and to the point. 2.63. What is the ratio of the Expenses (% of total expenses) in Other expenses in 1993 to that in 1996?
Offer a very short reply. 0.73. What is the ratio of the Expenses (% of total expenses) of Compensation of employees in 1993 to that in 1997?
Give a very brief answer. 0.36. What is the ratio of the Expenses (% of total expenses) of Goods and services in 1993 to that in 1997?
Your response must be concise. 1.66. What is the ratio of the Expenses (% of total expenses) in Subsidies and Transfers in 1993 to that in 1997?
Give a very brief answer. 0.28. What is the ratio of the Expenses (% of total expenses) of Other expenses in 1993 to that in 1997?
Make the answer very short. 0.84. What is the ratio of the Expenses (% of total expenses) in Compensation of employees in 1993 to that in 1998?
Keep it short and to the point. 0.41. What is the ratio of the Expenses (% of total expenses) in Goods and services in 1993 to that in 1998?
Offer a very short reply. 2.33. What is the ratio of the Expenses (% of total expenses) in Subsidies and Transfers in 1993 to that in 1998?
Ensure brevity in your answer.  1.72. What is the ratio of the Expenses (% of total expenses) of Other expenses in 1993 to that in 1998?
Your answer should be compact. 1.14. What is the ratio of the Expenses (% of total expenses) in Compensation of employees in 1994 to that in 1995?
Your answer should be compact. 0.37. What is the ratio of the Expenses (% of total expenses) in Goods and services in 1994 to that in 1995?
Ensure brevity in your answer.  1.27. What is the ratio of the Expenses (% of total expenses) of Subsidies and Transfers in 1994 to that in 1995?
Give a very brief answer. 0.86. What is the ratio of the Expenses (% of total expenses) of Other expenses in 1994 to that in 1995?
Offer a terse response. 0.78. What is the ratio of the Expenses (% of total expenses) of Compensation of employees in 1994 to that in 1996?
Your response must be concise. 0.38. What is the ratio of the Expenses (% of total expenses) of Goods and services in 1994 to that in 1996?
Your answer should be compact. 1.28. What is the ratio of the Expenses (% of total expenses) in Subsidies and Transfers in 1994 to that in 1996?
Provide a short and direct response. 0.71. What is the ratio of the Expenses (% of total expenses) in Other expenses in 1994 to that in 1996?
Keep it short and to the point. 0.91. What is the ratio of the Expenses (% of total expenses) of Compensation of employees in 1994 to that in 1997?
Provide a succinct answer. 0.39. What is the ratio of the Expenses (% of total expenses) in Goods and services in 1994 to that in 1997?
Keep it short and to the point. 1.15. What is the ratio of the Expenses (% of total expenses) in Subsidies and Transfers in 1994 to that in 1997?
Your answer should be very brief. 0.07. What is the ratio of the Expenses (% of total expenses) in Other expenses in 1994 to that in 1997?
Make the answer very short. 1.03. What is the ratio of the Expenses (% of total expenses) in Compensation of employees in 1994 to that in 1998?
Keep it short and to the point. 0.45. What is the ratio of the Expenses (% of total expenses) in Goods and services in 1994 to that in 1998?
Provide a succinct answer. 1.62. What is the ratio of the Expenses (% of total expenses) of Subsidies and Transfers in 1994 to that in 1998?
Offer a terse response. 0.46. What is the ratio of the Expenses (% of total expenses) of Other expenses in 1994 to that in 1998?
Provide a short and direct response. 1.41. What is the ratio of the Expenses (% of total expenses) in Compensation of employees in 1995 to that in 1996?
Provide a succinct answer. 1.02. What is the ratio of the Expenses (% of total expenses) in Subsidies and Transfers in 1995 to that in 1996?
Give a very brief answer. 0.83. What is the ratio of the Expenses (% of total expenses) of Other expenses in 1995 to that in 1996?
Make the answer very short. 1.16. What is the ratio of the Expenses (% of total expenses) of Compensation of employees in 1995 to that in 1997?
Provide a short and direct response. 1.06. What is the ratio of the Expenses (% of total expenses) in Goods and services in 1995 to that in 1997?
Provide a short and direct response. 0.91. What is the ratio of the Expenses (% of total expenses) in Subsidies and Transfers in 1995 to that in 1997?
Your response must be concise. 0.09. What is the ratio of the Expenses (% of total expenses) in Other expenses in 1995 to that in 1997?
Provide a short and direct response. 1.33. What is the ratio of the Expenses (% of total expenses) in Goods and services in 1995 to that in 1998?
Provide a succinct answer. 1.28. What is the ratio of the Expenses (% of total expenses) in Subsidies and Transfers in 1995 to that in 1998?
Provide a short and direct response. 0.54. What is the ratio of the Expenses (% of total expenses) in Other expenses in 1995 to that in 1998?
Your response must be concise. 1.81. What is the ratio of the Expenses (% of total expenses) of Compensation of employees in 1996 to that in 1997?
Make the answer very short. 1.03. What is the ratio of the Expenses (% of total expenses) of Goods and services in 1996 to that in 1997?
Provide a succinct answer. 0.9. What is the ratio of the Expenses (% of total expenses) in Subsidies and Transfers in 1996 to that in 1997?
Ensure brevity in your answer.  0.11. What is the ratio of the Expenses (% of total expenses) of Other expenses in 1996 to that in 1997?
Your answer should be very brief. 1.14. What is the ratio of the Expenses (% of total expenses) of Compensation of employees in 1996 to that in 1998?
Your answer should be very brief. 1.17. What is the ratio of the Expenses (% of total expenses) in Goods and services in 1996 to that in 1998?
Provide a succinct answer. 1.26. What is the ratio of the Expenses (% of total expenses) of Subsidies and Transfers in 1996 to that in 1998?
Your answer should be compact. 0.65. What is the ratio of the Expenses (% of total expenses) of Other expenses in 1996 to that in 1998?
Provide a short and direct response. 1.56. What is the ratio of the Expenses (% of total expenses) in Compensation of employees in 1997 to that in 1998?
Your answer should be very brief. 1.13. What is the ratio of the Expenses (% of total expenses) in Goods and services in 1997 to that in 1998?
Offer a very short reply. 1.4. What is the ratio of the Expenses (% of total expenses) in Subsidies and Transfers in 1997 to that in 1998?
Provide a succinct answer. 6.18. What is the ratio of the Expenses (% of total expenses) of Other expenses in 1997 to that in 1998?
Offer a terse response. 1.36. What is the difference between the highest and the second highest Expenses (% of total expenses) in Compensation of employees?
Ensure brevity in your answer.  1.32. What is the difference between the highest and the second highest Expenses (% of total expenses) of Goods and services?
Offer a terse response. 20.68. What is the difference between the highest and the second highest Expenses (% of total expenses) of Subsidies and Transfers?
Offer a terse response. 4.38. What is the difference between the highest and the second highest Expenses (% of total expenses) of Other expenses?
Offer a very short reply. 4.74. What is the difference between the highest and the lowest Expenses (% of total expenses) of Compensation of employees?
Give a very brief answer. 38.34. What is the difference between the highest and the lowest Expenses (% of total expenses) of Goods and services?
Provide a short and direct response. 38.57. What is the difference between the highest and the lowest Expenses (% of total expenses) in Subsidies and Transfers?
Provide a succinct answer. 5.62. What is the difference between the highest and the lowest Expenses (% of total expenses) of Other expenses?
Make the answer very short. 15.14. 